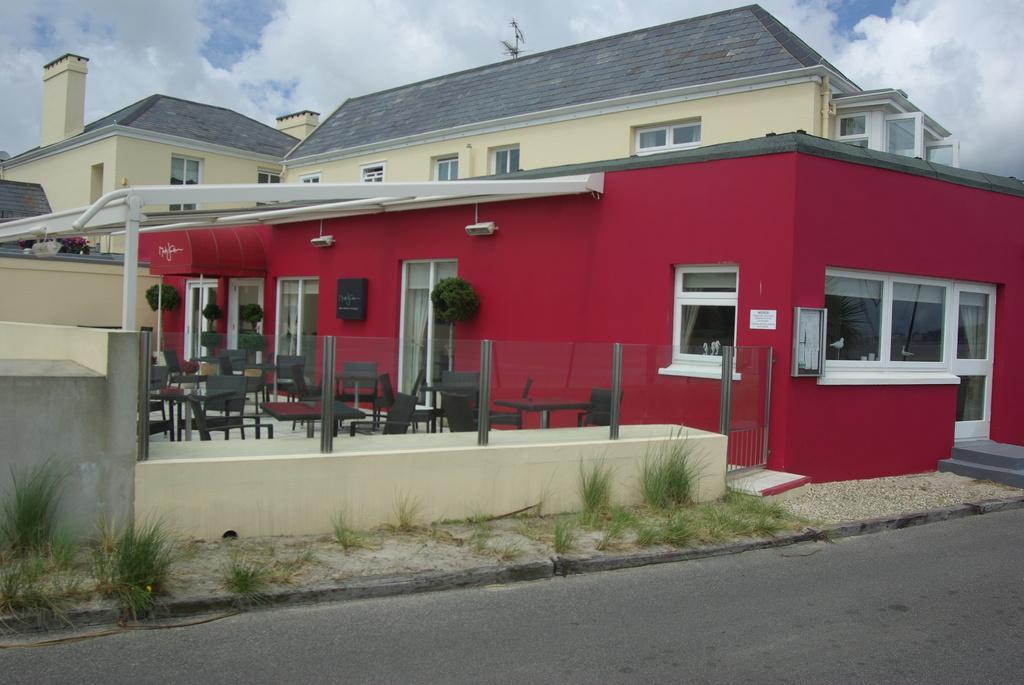How would you summarize this image in a sentence or two? In the center of the image there is a building. At the bottom there is a road and we can see grass. At the top there is sky. 